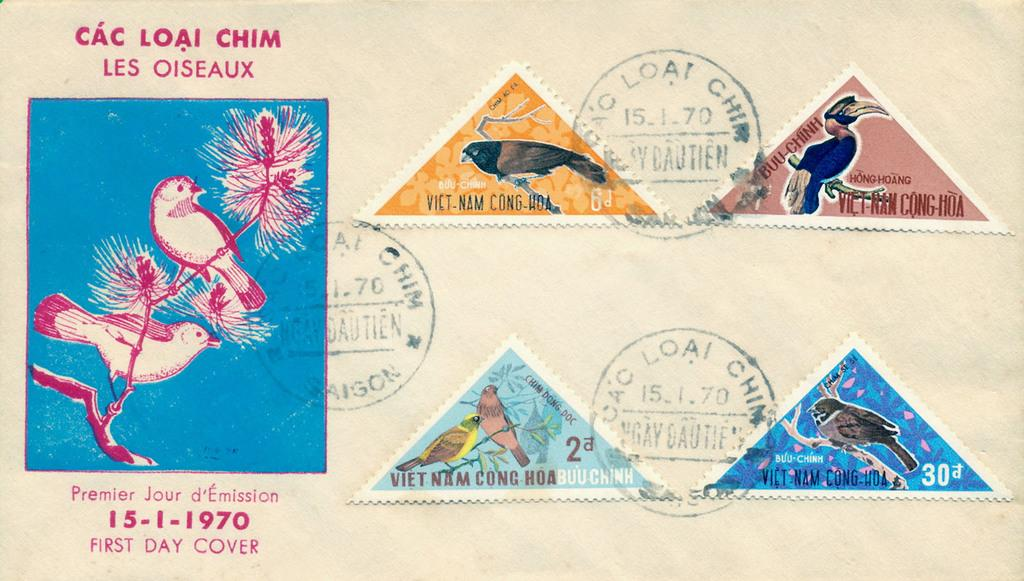What type of object is depicted in the image? The object is an envelope. What can be seen on the envelope's surface? There are stamps and a logo on the envelope. Is there any text present on the envelope? Yes, there is text on the envelope. How does the envelope generate steam in the image? The envelope does not generate steam in the image; there is no steam present. 